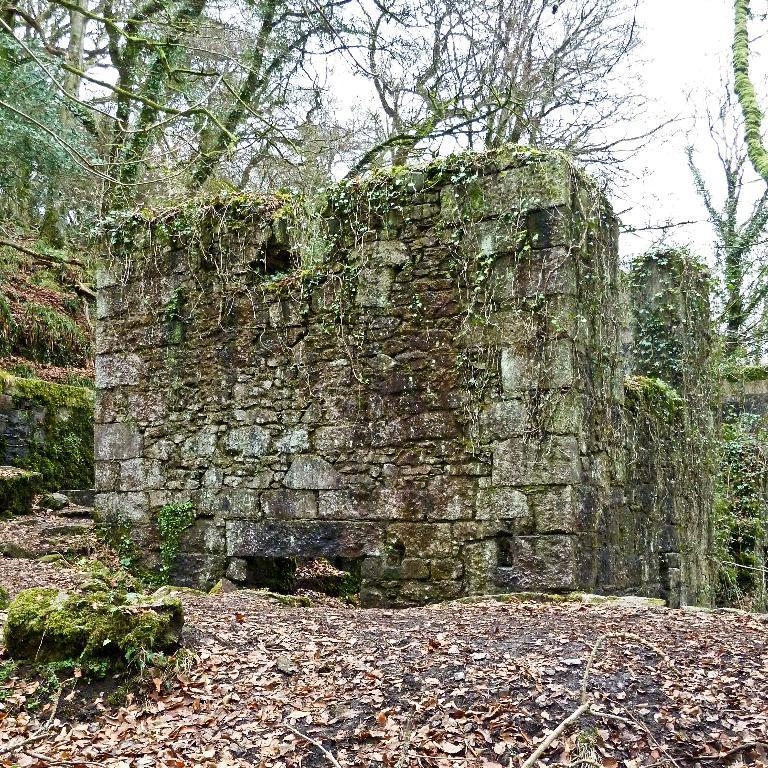Describe this image in one or two sentences. There is a wall in the middle of this image. We can see trees at the top of this image and the sky is in the background. 